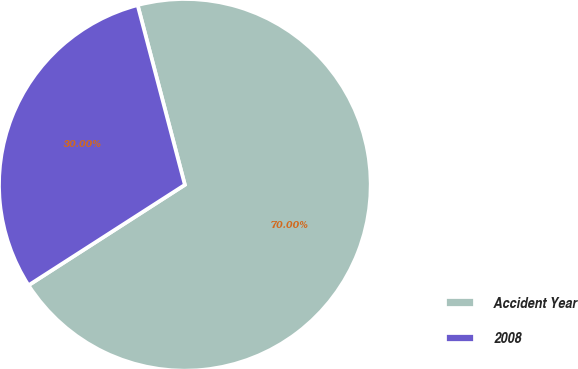Convert chart. <chart><loc_0><loc_0><loc_500><loc_500><pie_chart><fcel>Accident Year<fcel>2008<nl><fcel>70.0%<fcel>30.0%<nl></chart> 